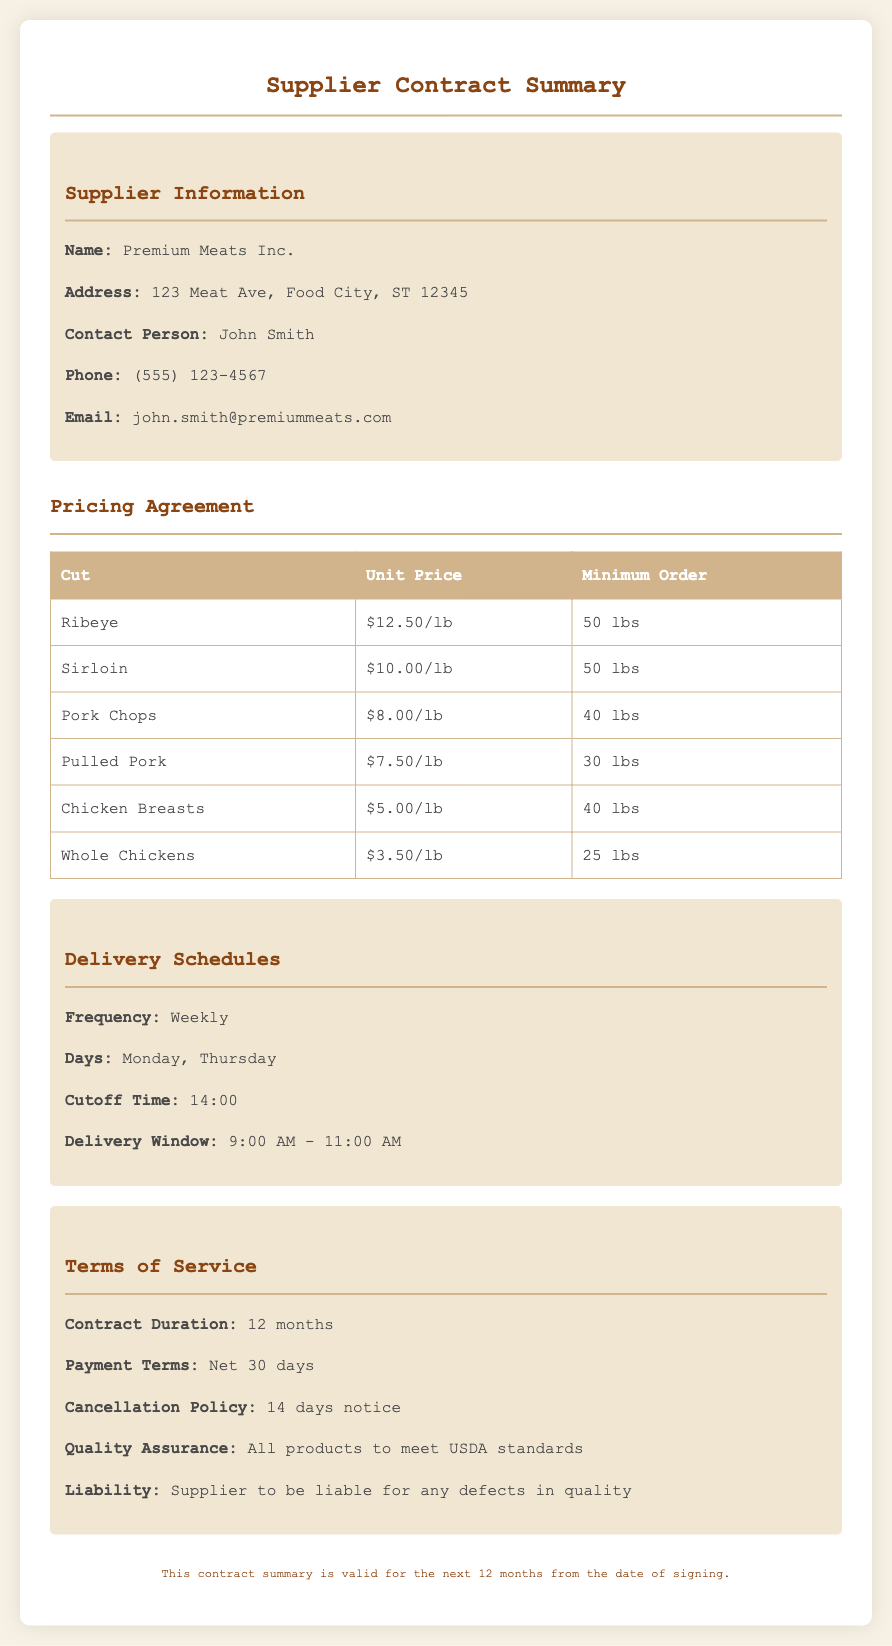what is the supplier name? The supplier name is listed in the document's header under Supplier Information.
Answer: Premium Meats Inc what is the unit price for Ribeye? The unit price for Ribeye is found in the Pricing Agreement section.
Answer: $12.50/lb how many pounds are required for the minimum order of Chicken Breasts? The minimum order for Chicken Breasts is specified in the Pricing Agreement table.
Answer: 40 lbs what is the delivery frequency? Delivery frequency is mentioned in the Delivery Schedules section of the document.
Answer: Weekly what is the cancellation policy? The cancellation policy is detailed in the Terms of Service section.
Answer: 14 days notice how often are deliveries scheduled? The delivery days are mentioned in the Delivery Schedules section, needing logic to infer the frequency based on days.
Answer: 2 times a week what is the payment term duration? The payment terms indicate the time frame stated in the Terms of Service section.
Answer: Net 30 days what is the contract duration? The duration of the contract is specified towards the end of the Terms of Service section.
Answer: 12 months what are the delivery days? The delivery days are detailed in the Delivery Schedules section of the document.
Answer: Monday, Thursday 